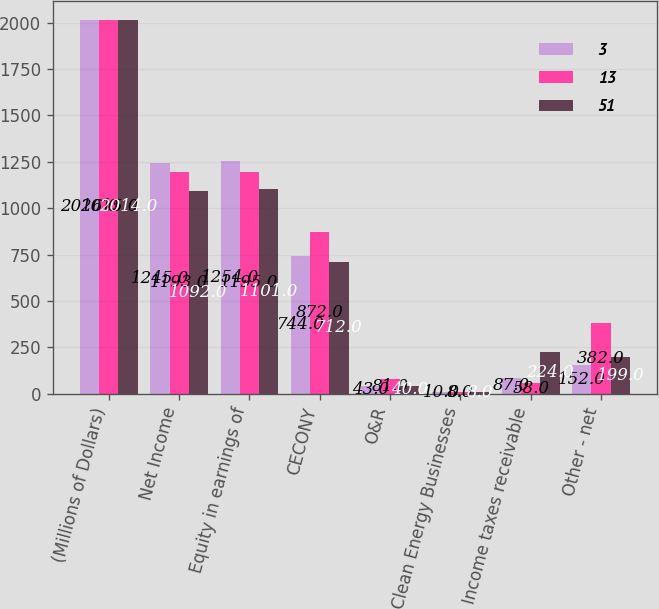Convert chart. <chart><loc_0><loc_0><loc_500><loc_500><stacked_bar_chart><ecel><fcel>(Millions of Dollars)<fcel>Net Income<fcel>Equity in earnings of<fcel>CECONY<fcel>O&R<fcel>Clean Energy Businesses<fcel>Income taxes receivable<fcel>Other - net<nl><fcel>3<fcel>2016<fcel>1245<fcel>1254<fcel>744<fcel>43<fcel>10<fcel>87<fcel>152<nl><fcel>13<fcel>2015<fcel>1193<fcel>1195<fcel>872<fcel>81<fcel>8<fcel>58<fcel>382<nl><fcel>51<fcel>2014<fcel>1092<fcel>1101<fcel>712<fcel>40<fcel>8<fcel>224<fcel>199<nl></chart> 